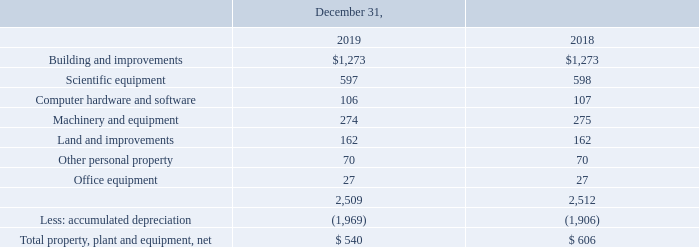NOTE 5 – PROPERTY, PLANT AND EQUIPMENT
Property, plant and equipment is summarized as follows (in thousands):
We do not have leasehold improvements nor do we have capitalized leases. Costs of betterments are capitalized while maintenance costs and repair costs are charged to operations as incurred. When a depreciable asset is retired from service, the cost and accumulated depreciation will be removed from the respective accounts.
Depreciation expense was $66 thousand and $73 thousand for each of the years ended December 31, 2019 and 2018, respectively.
What was the depreciation expense in 2018? $73 thousand. What are the accounting treatments for disposed assets? When a depreciable asset is retired from service, the cost and accumulated depreciation will be removed from the respective accounts. What is the net total for property, plant and equipment in 2019?
Answer scale should be: thousand. $ 540. How much of scientific equipment is being decapitalized from 2018 to 2019? 
Answer scale should be: thousand. 598 - 597 
Answer: 1. How much assets were decapitalized from 2018 to 2019?
Answer scale should be: thousand. 2,512 - 2,509 
Answer: 3. What is the percentage decrease in Net Total Property, Plant and Equipment from 2018 to 2019?
Answer scale should be: percent. (606 - 540) / 606 
Answer: 10.89. 